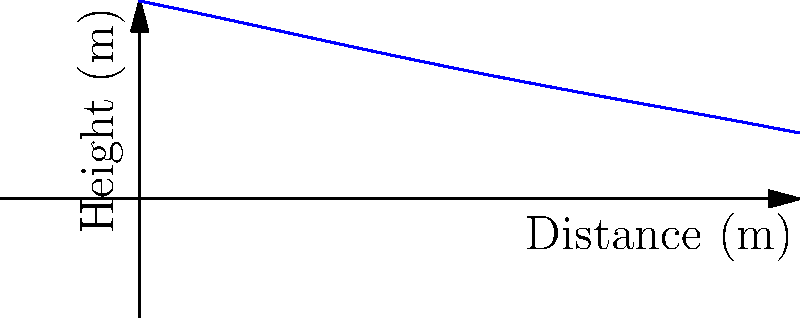The trajectory of your competitive dive is modeled by the fourth-degree polynomial function $f(x) = -0.0001x^4 + 0.002x^3 - 0.01x^2 - 0.2x + 3$, where $x$ is the horizontal distance from the starting point in meters, and $f(x)$ is the height in meters. At what horizontal distance from the starting point do you enter the water? To find the horizontal distance at which you enter the water, we need to determine where the height $f(x)$ becomes zero. This means solving the equation:

$$-0.0001x^4 + 0.002x^3 - 0.01x^2 - 0.2x + 3 = 0$$

This is a complex fourth-degree equation that cannot be easily solved by factoring. In competitive diving, we typically use numerical methods or graphing calculators to solve such equations.

Using a graphing calculator or computer software, we can find that the equation has two real roots:
1. $x \approx -0.05$ (which is not relevant as it's before the dive starts)
2. $x \approx 8.95$

The second root, $x \approx 8.95$, represents the point where the trajectory intersects the water surface (y = 0).

Therefore, you enter the water approximately 8.95 meters from your starting point.
Answer: 8.95 meters 